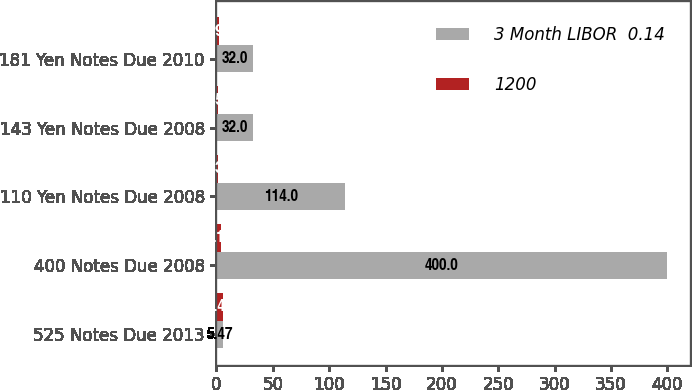<chart> <loc_0><loc_0><loc_500><loc_500><stacked_bar_chart><ecel><fcel>525 Notes Due 2013<fcel>400 Notes Due 2008<fcel>110 Yen Notes Due 2008<fcel>143 Yen Notes Due 2008<fcel>181 Yen Notes Due 2010<nl><fcel>3 Month LIBOR  0.14<fcel>5.47<fcel>400<fcel>114<fcel>32<fcel>32<nl><fcel>1200<fcel>5.47<fcel>4.19<fcel>1.33<fcel>1.59<fcel>1.94<nl></chart> 